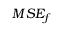<formula> <loc_0><loc_0><loc_500><loc_500>M S E _ { f }</formula> 